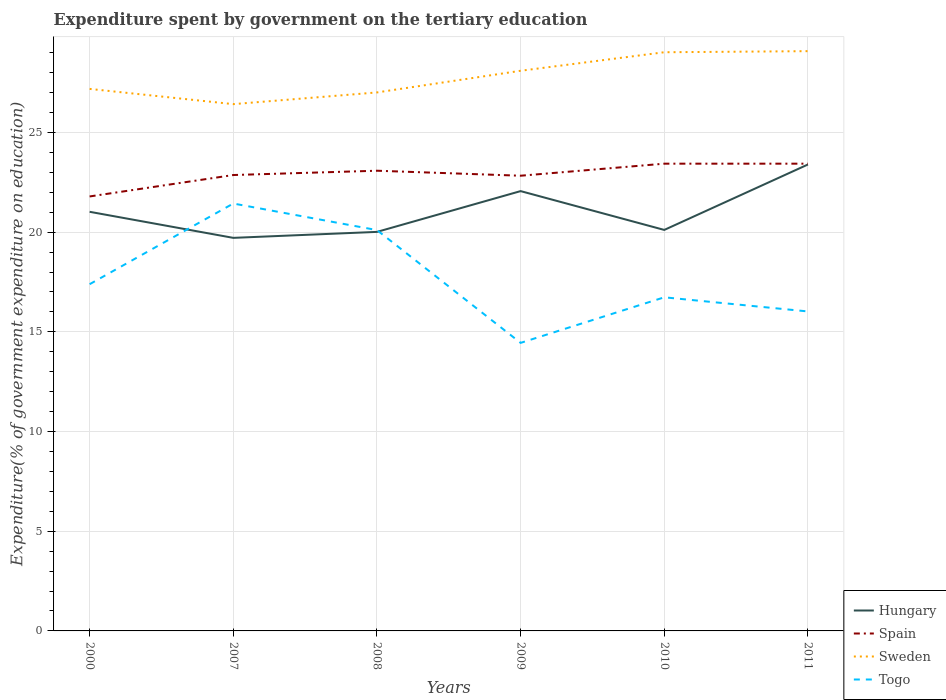How many different coloured lines are there?
Provide a succinct answer. 4. Does the line corresponding to Hungary intersect with the line corresponding to Spain?
Provide a short and direct response. No. Across all years, what is the maximum expenditure spent by government on the tertiary education in Togo?
Give a very brief answer. 14.45. In which year was the expenditure spent by government on the tertiary education in Sweden maximum?
Your answer should be compact. 2007. What is the total expenditure spent by government on the tertiary education in Spain in the graph?
Make the answer very short. -1.04. What is the difference between the highest and the second highest expenditure spent by government on the tertiary education in Hungary?
Your response must be concise. 3.68. What is the difference between the highest and the lowest expenditure spent by government on the tertiary education in Hungary?
Keep it short and to the point. 2. How many lines are there?
Offer a very short reply. 4. How many years are there in the graph?
Provide a succinct answer. 6. What is the difference between two consecutive major ticks on the Y-axis?
Provide a succinct answer. 5. Are the values on the major ticks of Y-axis written in scientific E-notation?
Your answer should be compact. No. Does the graph contain any zero values?
Provide a succinct answer. No. Where does the legend appear in the graph?
Provide a short and direct response. Bottom right. What is the title of the graph?
Give a very brief answer. Expenditure spent by government on the tertiary education. What is the label or title of the X-axis?
Make the answer very short. Years. What is the label or title of the Y-axis?
Provide a succinct answer. Expenditure(% of government expenditure on education). What is the Expenditure(% of government expenditure on education) in Hungary in 2000?
Provide a succinct answer. 21.02. What is the Expenditure(% of government expenditure on education) of Spain in 2000?
Offer a terse response. 21.79. What is the Expenditure(% of government expenditure on education) in Sweden in 2000?
Your answer should be compact. 27.18. What is the Expenditure(% of government expenditure on education) in Togo in 2000?
Provide a short and direct response. 17.39. What is the Expenditure(% of government expenditure on education) of Hungary in 2007?
Keep it short and to the point. 19.71. What is the Expenditure(% of government expenditure on education) of Spain in 2007?
Your answer should be very brief. 22.86. What is the Expenditure(% of government expenditure on education) of Sweden in 2007?
Your answer should be compact. 26.42. What is the Expenditure(% of government expenditure on education) in Togo in 2007?
Offer a terse response. 21.43. What is the Expenditure(% of government expenditure on education) of Hungary in 2008?
Provide a short and direct response. 20.01. What is the Expenditure(% of government expenditure on education) in Spain in 2008?
Make the answer very short. 23.08. What is the Expenditure(% of government expenditure on education) of Sweden in 2008?
Provide a short and direct response. 27.01. What is the Expenditure(% of government expenditure on education) of Togo in 2008?
Offer a terse response. 20.1. What is the Expenditure(% of government expenditure on education) in Hungary in 2009?
Offer a very short reply. 22.06. What is the Expenditure(% of government expenditure on education) of Spain in 2009?
Your response must be concise. 22.83. What is the Expenditure(% of government expenditure on education) in Sweden in 2009?
Make the answer very short. 28.09. What is the Expenditure(% of government expenditure on education) of Togo in 2009?
Offer a terse response. 14.45. What is the Expenditure(% of government expenditure on education) of Hungary in 2010?
Your answer should be compact. 20.11. What is the Expenditure(% of government expenditure on education) in Spain in 2010?
Your response must be concise. 23.43. What is the Expenditure(% of government expenditure on education) in Sweden in 2010?
Provide a succinct answer. 29.02. What is the Expenditure(% of government expenditure on education) in Togo in 2010?
Give a very brief answer. 16.73. What is the Expenditure(% of government expenditure on education) of Hungary in 2011?
Keep it short and to the point. 23.39. What is the Expenditure(% of government expenditure on education) in Spain in 2011?
Offer a terse response. 23.43. What is the Expenditure(% of government expenditure on education) of Sweden in 2011?
Provide a succinct answer. 29.08. What is the Expenditure(% of government expenditure on education) in Togo in 2011?
Provide a succinct answer. 16.02. Across all years, what is the maximum Expenditure(% of government expenditure on education) in Hungary?
Your answer should be compact. 23.39. Across all years, what is the maximum Expenditure(% of government expenditure on education) of Spain?
Keep it short and to the point. 23.43. Across all years, what is the maximum Expenditure(% of government expenditure on education) in Sweden?
Keep it short and to the point. 29.08. Across all years, what is the maximum Expenditure(% of government expenditure on education) of Togo?
Your answer should be very brief. 21.43. Across all years, what is the minimum Expenditure(% of government expenditure on education) in Hungary?
Your response must be concise. 19.71. Across all years, what is the minimum Expenditure(% of government expenditure on education) in Spain?
Keep it short and to the point. 21.79. Across all years, what is the minimum Expenditure(% of government expenditure on education) of Sweden?
Provide a succinct answer. 26.42. Across all years, what is the minimum Expenditure(% of government expenditure on education) in Togo?
Give a very brief answer. 14.45. What is the total Expenditure(% of government expenditure on education) in Hungary in the graph?
Offer a terse response. 126.31. What is the total Expenditure(% of government expenditure on education) in Spain in the graph?
Make the answer very short. 137.43. What is the total Expenditure(% of government expenditure on education) in Sweden in the graph?
Your response must be concise. 166.8. What is the total Expenditure(% of government expenditure on education) in Togo in the graph?
Your response must be concise. 106.13. What is the difference between the Expenditure(% of government expenditure on education) in Hungary in 2000 and that in 2007?
Keep it short and to the point. 1.31. What is the difference between the Expenditure(% of government expenditure on education) of Spain in 2000 and that in 2007?
Provide a succinct answer. -1.07. What is the difference between the Expenditure(% of government expenditure on education) in Sweden in 2000 and that in 2007?
Offer a terse response. 0.76. What is the difference between the Expenditure(% of government expenditure on education) in Togo in 2000 and that in 2007?
Ensure brevity in your answer.  -4.05. What is the difference between the Expenditure(% of government expenditure on education) of Hungary in 2000 and that in 2008?
Ensure brevity in your answer.  1.01. What is the difference between the Expenditure(% of government expenditure on education) of Spain in 2000 and that in 2008?
Make the answer very short. -1.29. What is the difference between the Expenditure(% of government expenditure on education) in Sweden in 2000 and that in 2008?
Ensure brevity in your answer.  0.18. What is the difference between the Expenditure(% of government expenditure on education) of Togo in 2000 and that in 2008?
Provide a short and direct response. -2.71. What is the difference between the Expenditure(% of government expenditure on education) of Hungary in 2000 and that in 2009?
Keep it short and to the point. -1.04. What is the difference between the Expenditure(% of government expenditure on education) in Spain in 2000 and that in 2009?
Keep it short and to the point. -1.04. What is the difference between the Expenditure(% of government expenditure on education) of Sweden in 2000 and that in 2009?
Ensure brevity in your answer.  -0.91. What is the difference between the Expenditure(% of government expenditure on education) in Togo in 2000 and that in 2009?
Make the answer very short. 2.94. What is the difference between the Expenditure(% of government expenditure on education) in Hungary in 2000 and that in 2010?
Offer a terse response. 0.91. What is the difference between the Expenditure(% of government expenditure on education) of Spain in 2000 and that in 2010?
Your response must be concise. -1.64. What is the difference between the Expenditure(% of government expenditure on education) of Sweden in 2000 and that in 2010?
Keep it short and to the point. -1.84. What is the difference between the Expenditure(% of government expenditure on education) in Togo in 2000 and that in 2010?
Offer a terse response. 0.66. What is the difference between the Expenditure(% of government expenditure on education) of Hungary in 2000 and that in 2011?
Your response must be concise. -2.37. What is the difference between the Expenditure(% of government expenditure on education) in Spain in 2000 and that in 2011?
Offer a terse response. -1.64. What is the difference between the Expenditure(% of government expenditure on education) of Sweden in 2000 and that in 2011?
Your response must be concise. -1.89. What is the difference between the Expenditure(% of government expenditure on education) in Togo in 2000 and that in 2011?
Your answer should be compact. 1.37. What is the difference between the Expenditure(% of government expenditure on education) in Hungary in 2007 and that in 2008?
Your answer should be compact. -0.3. What is the difference between the Expenditure(% of government expenditure on education) in Spain in 2007 and that in 2008?
Make the answer very short. -0.22. What is the difference between the Expenditure(% of government expenditure on education) of Sweden in 2007 and that in 2008?
Provide a short and direct response. -0.59. What is the difference between the Expenditure(% of government expenditure on education) in Togo in 2007 and that in 2008?
Offer a very short reply. 1.33. What is the difference between the Expenditure(% of government expenditure on education) of Hungary in 2007 and that in 2009?
Keep it short and to the point. -2.34. What is the difference between the Expenditure(% of government expenditure on education) of Spain in 2007 and that in 2009?
Provide a short and direct response. 0.03. What is the difference between the Expenditure(% of government expenditure on education) of Sweden in 2007 and that in 2009?
Offer a terse response. -1.67. What is the difference between the Expenditure(% of government expenditure on education) in Togo in 2007 and that in 2009?
Offer a terse response. 6.99. What is the difference between the Expenditure(% of government expenditure on education) of Hungary in 2007 and that in 2010?
Offer a terse response. -0.4. What is the difference between the Expenditure(% of government expenditure on education) of Spain in 2007 and that in 2010?
Make the answer very short. -0.57. What is the difference between the Expenditure(% of government expenditure on education) in Sweden in 2007 and that in 2010?
Give a very brief answer. -2.6. What is the difference between the Expenditure(% of government expenditure on education) in Togo in 2007 and that in 2010?
Your answer should be compact. 4.7. What is the difference between the Expenditure(% of government expenditure on education) of Hungary in 2007 and that in 2011?
Give a very brief answer. -3.68. What is the difference between the Expenditure(% of government expenditure on education) of Spain in 2007 and that in 2011?
Give a very brief answer. -0.57. What is the difference between the Expenditure(% of government expenditure on education) in Sweden in 2007 and that in 2011?
Give a very brief answer. -2.66. What is the difference between the Expenditure(% of government expenditure on education) of Togo in 2007 and that in 2011?
Your answer should be compact. 5.41. What is the difference between the Expenditure(% of government expenditure on education) of Hungary in 2008 and that in 2009?
Keep it short and to the point. -2.05. What is the difference between the Expenditure(% of government expenditure on education) in Spain in 2008 and that in 2009?
Ensure brevity in your answer.  0.25. What is the difference between the Expenditure(% of government expenditure on education) of Sweden in 2008 and that in 2009?
Ensure brevity in your answer.  -1.09. What is the difference between the Expenditure(% of government expenditure on education) of Togo in 2008 and that in 2009?
Give a very brief answer. 5.66. What is the difference between the Expenditure(% of government expenditure on education) of Hungary in 2008 and that in 2010?
Provide a succinct answer. -0.1. What is the difference between the Expenditure(% of government expenditure on education) of Spain in 2008 and that in 2010?
Provide a short and direct response. -0.35. What is the difference between the Expenditure(% of government expenditure on education) in Sweden in 2008 and that in 2010?
Provide a succinct answer. -2.02. What is the difference between the Expenditure(% of government expenditure on education) of Togo in 2008 and that in 2010?
Make the answer very short. 3.37. What is the difference between the Expenditure(% of government expenditure on education) of Hungary in 2008 and that in 2011?
Give a very brief answer. -3.38. What is the difference between the Expenditure(% of government expenditure on education) of Spain in 2008 and that in 2011?
Keep it short and to the point. -0.35. What is the difference between the Expenditure(% of government expenditure on education) of Sweden in 2008 and that in 2011?
Give a very brief answer. -2.07. What is the difference between the Expenditure(% of government expenditure on education) in Togo in 2008 and that in 2011?
Your response must be concise. 4.08. What is the difference between the Expenditure(% of government expenditure on education) in Hungary in 2009 and that in 2010?
Give a very brief answer. 1.95. What is the difference between the Expenditure(% of government expenditure on education) of Spain in 2009 and that in 2010?
Provide a succinct answer. -0.6. What is the difference between the Expenditure(% of government expenditure on education) of Sweden in 2009 and that in 2010?
Give a very brief answer. -0.93. What is the difference between the Expenditure(% of government expenditure on education) in Togo in 2009 and that in 2010?
Make the answer very short. -2.29. What is the difference between the Expenditure(% of government expenditure on education) in Hungary in 2009 and that in 2011?
Provide a short and direct response. -1.33. What is the difference between the Expenditure(% of government expenditure on education) of Spain in 2009 and that in 2011?
Your answer should be compact. -0.6. What is the difference between the Expenditure(% of government expenditure on education) in Sweden in 2009 and that in 2011?
Offer a very short reply. -0.98. What is the difference between the Expenditure(% of government expenditure on education) in Togo in 2009 and that in 2011?
Your answer should be compact. -1.58. What is the difference between the Expenditure(% of government expenditure on education) of Hungary in 2010 and that in 2011?
Your answer should be compact. -3.28. What is the difference between the Expenditure(% of government expenditure on education) of Sweden in 2010 and that in 2011?
Provide a succinct answer. -0.05. What is the difference between the Expenditure(% of government expenditure on education) in Togo in 2010 and that in 2011?
Make the answer very short. 0.71. What is the difference between the Expenditure(% of government expenditure on education) in Hungary in 2000 and the Expenditure(% of government expenditure on education) in Spain in 2007?
Keep it short and to the point. -1.84. What is the difference between the Expenditure(% of government expenditure on education) in Hungary in 2000 and the Expenditure(% of government expenditure on education) in Sweden in 2007?
Offer a terse response. -5.4. What is the difference between the Expenditure(% of government expenditure on education) of Hungary in 2000 and the Expenditure(% of government expenditure on education) of Togo in 2007?
Give a very brief answer. -0.42. What is the difference between the Expenditure(% of government expenditure on education) in Spain in 2000 and the Expenditure(% of government expenditure on education) in Sweden in 2007?
Offer a very short reply. -4.63. What is the difference between the Expenditure(% of government expenditure on education) of Spain in 2000 and the Expenditure(% of government expenditure on education) of Togo in 2007?
Offer a very short reply. 0.35. What is the difference between the Expenditure(% of government expenditure on education) in Sweden in 2000 and the Expenditure(% of government expenditure on education) in Togo in 2007?
Your response must be concise. 5.75. What is the difference between the Expenditure(% of government expenditure on education) of Hungary in 2000 and the Expenditure(% of government expenditure on education) of Spain in 2008?
Provide a succinct answer. -2.06. What is the difference between the Expenditure(% of government expenditure on education) of Hungary in 2000 and the Expenditure(% of government expenditure on education) of Sweden in 2008?
Keep it short and to the point. -5.99. What is the difference between the Expenditure(% of government expenditure on education) of Hungary in 2000 and the Expenditure(% of government expenditure on education) of Togo in 2008?
Your answer should be very brief. 0.92. What is the difference between the Expenditure(% of government expenditure on education) of Spain in 2000 and the Expenditure(% of government expenditure on education) of Sweden in 2008?
Provide a short and direct response. -5.22. What is the difference between the Expenditure(% of government expenditure on education) in Spain in 2000 and the Expenditure(% of government expenditure on education) in Togo in 2008?
Your answer should be very brief. 1.69. What is the difference between the Expenditure(% of government expenditure on education) of Sweden in 2000 and the Expenditure(% of government expenditure on education) of Togo in 2008?
Your response must be concise. 7.08. What is the difference between the Expenditure(% of government expenditure on education) of Hungary in 2000 and the Expenditure(% of government expenditure on education) of Spain in 2009?
Your answer should be very brief. -1.81. What is the difference between the Expenditure(% of government expenditure on education) in Hungary in 2000 and the Expenditure(% of government expenditure on education) in Sweden in 2009?
Give a very brief answer. -7.07. What is the difference between the Expenditure(% of government expenditure on education) in Hungary in 2000 and the Expenditure(% of government expenditure on education) in Togo in 2009?
Offer a very short reply. 6.57. What is the difference between the Expenditure(% of government expenditure on education) of Spain in 2000 and the Expenditure(% of government expenditure on education) of Sweden in 2009?
Provide a short and direct response. -6.3. What is the difference between the Expenditure(% of government expenditure on education) in Spain in 2000 and the Expenditure(% of government expenditure on education) in Togo in 2009?
Provide a succinct answer. 7.34. What is the difference between the Expenditure(% of government expenditure on education) of Sweden in 2000 and the Expenditure(% of government expenditure on education) of Togo in 2009?
Offer a very short reply. 12.74. What is the difference between the Expenditure(% of government expenditure on education) in Hungary in 2000 and the Expenditure(% of government expenditure on education) in Spain in 2010?
Make the answer very short. -2.41. What is the difference between the Expenditure(% of government expenditure on education) in Hungary in 2000 and the Expenditure(% of government expenditure on education) in Sweden in 2010?
Keep it short and to the point. -8. What is the difference between the Expenditure(% of government expenditure on education) in Hungary in 2000 and the Expenditure(% of government expenditure on education) in Togo in 2010?
Provide a succinct answer. 4.29. What is the difference between the Expenditure(% of government expenditure on education) of Spain in 2000 and the Expenditure(% of government expenditure on education) of Sweden in 2010?
Offer a terse response. -7.23. What is the difference between the Expenditure(% of government expenditure on education) of Spain in 2000 and the Expenditure(% of government expenditure on education) of Togo in 2010?
Your response must be concise. 5.06. What is the difference between the Expenditure(% of government expenditure on education) in Sweden in 2000 and the Expenditure(% of government expenditure on education) in Togo in 2010?
Make the answer very short. 10.45. What is the difference between the Expenditure(% of government expenditure on education) of Hungary in 2000 and the Expenditure(% of government expenditure on education) of Spain in 2011?
Provide a short and direct response. -2.41. What is the difference between the Expenditure(% of government expenditure on education) of Hungary in 2000 and the Expenditure(% of government expenditure on education) of Sweden in 2011?
Provide a succinct answer. -8.06. What is the difference between the Expenditure(% of government expenditure on education) in Hungary in 2000 and the Expenditure(% of government expenditure on education) in Togo in 2011?
Make the answer very short. 5. What is the difference between the Expenditure(% of government expenditure on education) of Spain in 2000 and the Expenditure(% of government expenditure on education) of Sweden in 2011?
Your answer should be compact. -7.29. What is the difference between the Expenditure(% of government expenditure on education) of Spain in 2000 and the Expenditure(% of government expenditure on education) of Togo in 2011?
Ensure brevity in your answer.  5.77. What is the difference between the Expenditure(% of government expenditure on education) in Sweden in 2000 and the Expenditure(% of government expenditure on education) in Togo in 2011?
Provide a succinct answer. 11.16. What is the difference between the Expenditure(% of government expenditure on education) in Hungary in 2007 and the Expenditure(% of government expenditure on education) in Spain in 2008?
Offer a very short reply. -3.37. What is the difference between the Expenditure(% of government expenditure on education) of Hungary in 2007 and the Expenditure(% of government expenditure on education) of Sweden in 2008?
Provide a succinct answer. -7.29. What is the difference between the Expenditure(% of government expenditure on education) of Hungary in 2007 and the Expenditure(% of government expenditure on education) of Togo in 2008?
Your response must be concise. -0.39. What is the difference between the Expenditure(% of government expenditure on education) of Spain in 2007 and the Expenditure(% of government expenditure on education) of Sweden in 2008?
Ensure brevity in your answer.  -4.14. What is the difference between the Expenditure(% of government expenditure on education) in Spain in 2007 and the Expenditure(% of government expenditure on education) in Togo in 2008?
Provide a short and direct response. 2.76. What is the difference between the Expenditure(% of government expenditure on education) of Sweden in 2007 and the Expenditure(% of government expenditure on education) of Togo in 2008?
Provide a short and direct response. 6.32. What is the difference between the Expenditure(% of government expenditure on education) in Hungary in 2007 and the Expenditure(% of government expenditure on education) in Spain in 2009?
Give a very brief answer. -3.12. What is the difference between the Expenditure(% of government expenditure on education) in Hungary in 2007 and the Expenditure(% of government expenditure on education) in Sweden in 2009?
Offer a very short reply. -8.38. What is the difference between the Expenditure(% of government expenditure on education) of Hungary in 2007 and the Expenditure(% of government expenditure on education) of Togo in 2009?
Keep it short and to the point. 5.27. What is the difference between the Expenditure(% of government expenditure on education) in Spain in 2007 and the Expenditure(% of government expenditure on education) in Sweden in 2009?
Your response must be concise. -5.23. What is the difference between the Expenditure(% of government expenditure on education) of Spain in 2007 and the Expenditure(% of government expenditure on education) of Togo in 2009?
Give a very brief answer. 8.42. What is the difference between the Expenditure(% of government expenditure on education) in Sweden in 2007 and the Expenditure(% of government expenditure on education) in Togo in 2009?
Give a very brief answer. 11.97. What is the difference between the Expenditure(% of government expenditure on education) in Hungary in 2007 and the Expenditure(% of government expenditure on education) in Spain in 2010?
Keep it short and to the point. -3.72. What is the difference between the Expenditure(% of government expenditure on education) in Hungary in 2007 and the Expenditure(% of government expenditure on education) in Sweden in 2010?
Ensure brevity in your answer.  -9.31. What is the difference between the Expenditure(% of government expenditure on education) in Hungary in 2007 and the Expenditure(% of government expenditure on education) in Togo in 2010?
Provide a succinct answer. 2.98. What is the difference between the Expenditure(% of government expenditure on education) in Spain in 2007 and the Expenditure(% of government expenditure on education) in Sweden in 2010?
Keep it short and to the point. -6.16. What is the difference between the Expenditure(% of government expenditure on education) of Spain in 2007 and the Expenditure(% of government expenditure on education) of Togo in 2010?
Provide a succinct answer. 6.13. What is the difference between the Expenditure(% of government expenditure on education) in Sweden in 2007 and the Expenditure(% of government expenditure on education) in Togo in 2010?
Keep it short and to the point. 9.69. What is the difference between the Expenditure(% of government expenditure on education) of Hungary in 2007 and the Expenditure(% of government expenditure on education) of Spain in 2011?
Provide a short and direct response. -3.72. What is the difference between the Expenditure(% of government expenditure on education) of Hungary in 2007 and the Expenditure(% of government expenditure on education) of Sweden in 2011?
Ensure brevity in your answer.  -9.36. What is the difference between the Expenditure(% of government expenditure on education) of Hungary in 2007 and the Expenditure(% of government expenditure on education) of Togo in 2011?
Offer a terse response. 3.69. What is the difference between the Expenditure(% of government expenditure on education) in Spain in 2007 and the Expenditure(% of government expenditure on education) in Sweden in 2011?
Your answer should be compact. -6.21. What is the difference between the Expenditure(% of government expenditure on education) of Spain in 2007 and the Expenditure(% of government expenditure on education) of Togo in 2011?
Offer a very short reply. 6.84. What is the difference between the Expenditure(% of government expenditure on education) of Sweden in 2007 and the Expenditure(% of government expenditure on education) of Togo in 2011?
Make the answer very short. 10.4. What is the difference between the Expenditure(% of government expenditure on education) in Hungary in 2008 and the Expenditure(% of government expenditure on education) in Spain in 2009?
Provide a short and direct response. -2.82. What is the difference between the Expenditure(% of government expenditure on education) in Hungary in 2008 and the Expenditure(% of government expenditure on education) in Sweden in 2009?
Provide a short and direct response. -8.08. What is the difference between the Expenditure(% of government expenditure on education) in Hungary in 2008 and the Expenditure(% of government expenditure on education) in Togo in 2009?
Offer a very short reply. 5.57. What is the difference between the Expenditure(% of government expenditure on education) of Spain in 2008 and the Expenditure(% of government expenditure on education) of Sweden in 2009?
Give a very brief answer. -5.01. What is the difference between the Expenditure(% of government expenditure on education) in Spain in 2008 and the Expenditure(% of government expenditure on education) in Togo in 2009?
Give a very brief answer. 8.63. What is the difference between the Expenditure(% of government expenditure on education) of Sweden in 2008 and the Expenditure(% of government expenditure on education) of Togo in 2009?
Make the answer very short. 12.56. What is the difference between the Expenditure(% of government expenditure on education) of Hungary in 2008 and the Expenditure(% of government expenditure on education) of Spain in 2010?
Give a very brief answer. -3.42. What is the difference between the Expenditure(% of government expenditure on education) in Hungary in 2008 and the Expenditure(% of government expenditure on education) in Sweden in 2010?
Make the answer very short. -9.01. What is the difference between the Expenditure(% of government expenditure on education) of Hungary in 2008 and the Expenditure(% of government expenditure on education) of Togo in 2010?
Give a very brief answer. 3.28. What is the difference between the Expenditure(% of government expenditure on education) in Spain in 2008 and the Expenditure(% of government expenditure on education) in Sweden in 2010?
Your answer should be compact. -5.94. What is the difference between the Expenditure(% of government expenditure on education) in Spain in 2008 and the Expenditure(% of government expenditure on education) in Togo in 2010?
Offer a terse response. 6.35. What is the difference between the Expenditure(% of government expenditure on education) in Sweden in 2008 and the Expenditure(% of government expenditure on education) in Togo in 2010?
Make the answer very short. 10.28. What is the difference between the Expenditure(% of government expenditure on education) in Hungary in 2008 and the Expenditure(% of government expenditure on education) in Spain in 2011?
Give a very brief answer. -3.42. What is the difference between the Expenditure(% of government expenditure on education) of Hungary in 2008 and the Expenditure(% of government expenditure on education) of Sweden in 2011?
Provide a succinct answer. -9.06. What is the difference between the Expenditure(% of government expenditure on education) in Hungary in 2008 and the Expenditure(% of government expenditure on education) in Togo in 2011?
Offer a very short reply. 3.99. What is the difference between the Expenditure(% of government expenditure on education) in Spain in 2008 and the Expenditure(% of government expenditure on education) in Sweden in 2011?
Your response must be concise. -6. What is the difference between the Expenditure(% of government expenditure on education) of Spain in 2008 and the Expenditure(% of government expenditure on education) of Togo in 2011?
Keep it short and to the point. 7.06. What is the difference between the Expenditure(% of government expenditure on education) of Sweden in 2008 and the Expenditure(% of government expenditure on education) of Togo in 2011?
Offer a terse response. 10.98. What is the difference between the Expenditure(% of government expenditure on education) in Hungary in 2009 and the Expenditure(% of government expenditure on education) in Spain in 2010?
Offer a terse response. -1.38. What is the difference between the Expenditure(% of government expenditure on education) in Hungary in 2009 and the Expenditure(% of government expenditure on education) in Sweden in 2010?
Offer a terse response. -6.96. What is the difference between the Expenditure(% of government expenditure on education) of Hungary in 2009 and the Expenditure(% of government expenditure on education) of Togo in 2010?
Keep it short and to the point. 5.33. What is the difference between the Expenditure(% of government expenditure on education) in Spain in 2009 and the Expenditure(% of government expenditure on education) in Sweden in 2010?
Your answer should be compact. -6.19. What is the difference between the Expenditure(% of government expenditure on education) in Spain in 2009 and the Expenditure(% of government expenditure on education) in Togo in 2010?
Provide a short and direct response. 6.1. What is the difference between the Expenditure(% of government expenditure on education) in Sweden in 2009 and the Expenditure(% of government expenditure on education) in Togo in 2010?
Provide a short and direct response. 11.36. What is the difference between the Expenditure(% of government expenditure on education) in Hungary in 2009 and the Expenditure(% of government expenditure on education) in Spain in 2011?
Your answer should be compact. -1.38. What is the difference between the Expenditure(% of government expenditure on education) of Hungary in 2009 and the Expenditure(% of government expenditure on education) of Sweden in 2011?
Your response must be concise. -7.02. What is the difference between the Expenditure(% of government expenditure on education) of Hungary in 2009 and the Expenditure(% of government expenditure on education) of Togo in 2011?
Make the answer very short. 6.04. What is the difference between the Expenditure(% of government expenditure on education) of Spain in 2009 and the Expenditure(% of government expenditure on education) of Sweden in 2011?
Give a very brief answer. -6.25. What is the difference between the Expenditure(% of government expenditure on education) in Spain in 2009 and the Expenditure(% of government expenditure on education) in Togo in 2011?
Your response must be concise. 6.81. What is the difference between the Expenditure(% of government expenditure on education) of Sweden in 2009 and the Expenditure(% of government expenditure on education) of Togo in 2011?
Provide a succinct answer. 12.07. What is the difference between the Expenditure(% of government expenditure on education) of Hungary in 2010 and the Expenditure(% of government expenditure on education) of Spain in 2011?
Your response must be concise. -3.32. What is the difference between the Expenditure(% of government expenditure on education) of Hungary in 2010 and the Expenditure(% of government expenditure on education) of Sweden in 2011?
Your answer should be compact. -8.97. What is the difference between the Expenditure(% of government expenditure on education) of Hungary in 2010 and the Expenditure(% of government expenditure on education) of Togo in 2011?
Keep it short and to the point. 4.09. What is the difference between the Expenditure(% of government expenditure on education) in Spain in 2010 and the Expenditure(% of government expenditure on education) in Sweden in 2011?
Offer a very short reply. -5.64. What is the difference between the Expenditure(% of government expenditure on education) in Spain in 2010 and the Expenditure(% of government expenditure on education) in Togo in 2011?
Your answer should be compact. 7.41. What is the difference between the Expenditure(% of government expenditure on education) of Sweden in 2010 and the Expenditure(% of government expenditure on education) of Togo in 2011?
Offer a terse response. 13. What is the average Expenditure(% of government expenditure on education) in Hungary per year?
Provide a succinct answer. 21.05. What is the average Expenditure(% of government expenditure on education) in Spain per year?
Your response must be concise. 22.9. What is the average Expenditure(% of government expenditure on education) in Sweden per year?
Give a very brief answer. 27.8. What is the average Expenditure(% of government expenditure on education) in Togo per year?
Offer a terse response. 17.69. In the year 2000, what is the difference between the Expenditure(% of government expenditure on education) of Hungary and Expenditure(% of government expenditure on education) of Spain?
Ensure brevity in your answer.  -0.77. In the year 2000, what is the difference between the Expenditure(% of government expenditure on education) of Hungary and Expenditure(% of government expenditure on education) of Sweden?
Keep it short and to the point. -6.16. In the year 2000, what is the difference between the Expenditure(% of government expenditure on education) of Hungary and Expenditure(% of government expenditure on education) of Togo?
Provide a short and direct response. 3.63. In the year 2000, what is the difference between the Expenditure(% of government expenditure on education) of Spain and Expenditure(% of government expenditure on education) of Sweden?
Offer a very short reply. -5.39. In the year 2000, what is the difference between the Expenditure(% of government expenditure on education) in Spain and Expenditure(% of government expenditure on education) in Togo?
Your response must be concise. 4.4. In the year 2000, what is the difference between the Expenditure(% of government expenditure on education) in Sweden and Expenditure(% of government expenditure on education) in Togo?
Keep it short and to the point. 9.79. In the year 2007, what is the difference between the Expenditure(% of government expenditure on education) in Hungary and Expenditure(% of government expenditure on education) in Spain?
Offer a terse response. -3.15. In the year 2007, what is the difference between the Expenditure(% of government expenditure on education) of Hungary and Expenditure(% of government expenditure on education) of Sweden?
Your response must be concise. -6.71. In the year 2007, what is the difference between the Expenditure(% of government expenditure on education) of Hungary and Expenditure(% of government expenditure on education) of Togo?
Ensure brevity in your answer.  -1.72. In the year 2007, what is the difference between the Expenditure(% of government expenditure on education) of Spain and Expenditure(% of government expenditure on education) of Sweden?
Offer a very short reply. -3.56. In the year 2007, what is the difference between the Expenditure(% of government expenditure on education) of Spain and Expenditure(% of government expenditure on education) of Togo?
Give a very brief answer. 1.43. In the year 2007, what is the difference between the Expenditure(% of government expenditure on education) of Sweden and Expenditure(% of government expenditure on education) of Togo?
Provide a short and direct response. 4.98. In the year 2008, what is the difference between the Expenditure(% of government expenditure on education) in Hungary and Expenditure(% of government expenditure on education) in Spain?
Your response must be concise. -3.07. In the year 2008, what is the difference between the Expenditure(% of government expenditure on education) of Hungary and Expenditure(% of government expenditure on education) of Sweden?
Your response must be concise. -6.99. In the year 2008, what is the difference between the Expenditure(% of government expenditure on education) of Hungary and Expenditure(% of government expenditure on education) of Togo?
Keep it short and to the point. -0.09. In the year 2008, what is the difference between the Expenditure(% of government expenditure on education) of Spain and Expenditure(% of government expenditure on education) of Sweden?
Your answer should be very brief. -3.93. In the year 2008, what is the difference between the Expenditure(% of government expenditure on education) in Spain and Expenditure(% of government expenditure on education) in Togo?
Make the answer very short. 2.98. In the year 2008, what is the difference between the Expenditure(% of government expenditure on education) in Sweden and Expenditure(% of government expenditure on education) in Togo?
Provide a succinct answer. 6.9. In the year 2009, what is the difference between the Expenditure(% of government expenditure on education) of Hungary and Expenditure(% of government expenditure on education) of Spain?
Provide a short and direct response. -0.77. In the year 2009, what is the difference between the Expenditure(% of government expenditure on education) of Hungary and Expenditure(% of government expenditure on education) of Sweden?
Make the answer very short. -6.04. In the year 2009, what is the difference between the Expenditure(% of government expenditure on education) of Hungary and Expenditure(% of government expenditure on education) of Togo?
Give a very brief answer. 7.61. In the year 2009, what is the difference between the Expenditure(% of government expenditure on education) in Spain and Expenditure(% of government expenditure on education) in Sweden?
Your answer should be very brief. -5.26. In the year 2009, what is the difference between the Expenditure(% of government expenditure on education) of Spain and Expenditure(% of government expenditure on education) of Togo?
Your answer should be compact. 8.38. In the year 2009, what is the difference between the Expenditure(% of government expenditure on education) of Sweden and Expenditure(% of government expenditure on education) of Togo?
Provide a short and direct response. 13.65. In the year 2010, what is the difference between the Expenditure(% of government expenditure on education) in Hungary and Expenditure(% of government expenditure on education) in Spain?
Make the answer very short. -3.32. In the year 2010, what is the difference between the Expenditure(% of government expenditure on education) in Hungary and Expenditure(% of government expenditure on education) in Sweden?
Give a very brief answer. -8.91. In the year 2010, what is the difference between the Expenditure(% of government expenditure on education) of Hungary and Expenditure(% of government expenditure on education) of Togo?
Your response must be concise. 3.38. In the year 2010, what is the difference between the Expenditure(% of government expenditure on education) of Spain and Expenditure(% of government expenditure on education) of Sweden?
Provide a short and direct response. -5.59. In the year 2010, what is the difference between the Expenditure(% of government expenditure on education) of Spain and Expenditure(% of government expenditure on education) of Togo?
Make the answer very short. 6.7. In the year 2010, what is the difference between the Expenditure(% of government expenditure on education) in Sweden and Expenditure(% of government expenditure on education) in Togo?
Your answer should be compact. 12.29. In the year 2011, what is the difference between the Expenditure(% of government expenditure on education) of Hungary and Expenditure(% of government expenditure on education) of Spain?
Your response must be concise. -0.04. In the year 2011, what is the difference between the Expenditure(% of government expenditure on education) of Hungary and Expenditure(% of government expenditure on education) of Sweden?
Keep it short and to the point. -5.68. In the year 2011, what is the difference between the Expenditure(% of government expenditure on education) in Hungary and Expenditure(% of government expenditure on education) in Togo?
Offer a very short reply. 7.37. In the year 2011, what is the difference between the Expenditure(% of government expenditure on education) of Spain and Expenditure(% of government expenditure on education) of Sweden?
Offer a very short reply. -5.64. In the year 2011, what is the difference between the Expenditure(% of government expenditure on education) in Spain and Expenditure(% of government expenditure on education) in Togo?
Provide a short and direct response. 7.41. In the year 2011, what is the difference between the Expenditure(% of government expenditure on education) in Sweden and Expenditure(% of government expenditure on education) in Togo?
Offer a terse response. 13.05. What is the ratio of the Expenditure(% of government expenditure on education) of Hungary in 2000 to that in 2007?
Give a very brief answer. 1.07. What is the ratio of the Expenditure(% of government expenditure on education) of Spain in 2000 to that in 2007?
Make the answer very short. 0.95. What is the ratio of the Expenditure(% of government expenditure on education) of Sweden in 2000 to that in 2007?
Provide a succinct answer. 1.03. What is the ratio of the Expenditure(% of government expenditure on education) in Togo in 2000 to that in 2007?
Provide a succinct answer. 0.81. What is the ratio of the Expenditure(% of government expenditure on education) in Hungary in 2000 to that in 2008?
Your response must be concise. 1.05. What is the ratio of the Expenditure(% of government expenditure on education) of Spain in 2000 to that in 2008?
Your answer should be compact. 0.94. What is the ratio of the Expenditure(% of government expenditure on education) in Togo in 2000 to that in 2008?
Offer a terse response. 0.86. What is the ratio of the Expenditure(% of government expenditure on education) in Hungary in 2000 to that in 2009?
Your response must be concise. 0.95. What is the ratio of the Expenditure(% of government expenditure on education) of Spain in 2000 to that in 2009?
Offer a terse response. 0.95. What is the ratio of the Expenditure(% of government expenditure on education) of Sweden in 2000 to that in 2009?
Make the answer very short. 0.97. What is the ratio of the Expenditure(% of government expenditure on education) in Togo in 2000 to that in 2009?
Your answer should be compact. 1.2. What is the ratio of the Expenditure(% of government expenditure on education) in Hungary in 2000 to that in 2010?
Your answer should be very brief. 1.05. What is the ratio of the Expenditure(% of government expenditure on education) in Spain in 2000 to that in 2010?
Provide a succinct answer. 0.93. What is the ratio of the Expenditure(% of government expenditure on education) of Sweden in 2000 to that in 2010?
Your response must be concise. 0.94. What is the ratio of the Expenditure(% of government expenditure on education) in Togo in 2000 to that in 2010?
Your response must be concise. 1.04. What is the ratio of the Expenditure(% of government expenditure on education) of Hungary in 2000 to that in 2011?
Provide a short and direct response. 0.9. What is the ratio of the Expenditure(% of government expenditure on education) of Spain in 2000 to that in 2011?
Keep it short and to the point. 0.93. What is the ratio of the Expenditure(% of government expenditure on education) of Sweden in 2000 to that in 2011?
Give a very brief answer. 0.93. What is the ratio of the Expenditure(% of government expenditure on education) in Togo in 2000 to that in 2011?
Offer a very short reply. 1.09. What is the ratio of the Expenditure(% of government expenditure on education) of Hungary in 2007 to that in 2008?
Ensure brevity in your answer.  0.99. What is the ratio of the Expenditure(% of government expenditure on education) in Spain in 2007 to that in 2008?
Offer a terse response. 0.99. What is the ratio of the Expenditure(% of government expenditure on education) of Sweden in 2007 to that in 2008?
Give a very brief answer. 0.98. What is the ratio of the Expenditure(% of government expenditure on education) of Togo in 2007 to that in 2008?
Make the answer very short. 1.07. What is the ratio of the Expenditure(% of government expenditure on education) in Hungary in 2007 to that in 2009?
Your answer should be very brief. 0.89. What is the ratio of the Expenditure(% of government expenditure on education) of Spain in 2007 to that in 2009?
Your answer should be very brief. 1. What is the ratio of the Expenditure(% of government expenditure on education) in Sweden in 2007 to that in 2009?
Your answer should be very brief. 0.94. What is the ratio of the Expenditure(% of government expenditure on education) in Togo in 2007 to that in 2009?
Your response must be concise. 1.48. What is the ratio of the Expenditure(% of government expenditure on education) of Hungary in 2007 to that in 2010?
Ensure brevity in your answer.  0.98. What is the ratio of the Expenditure(% of government expenditure on education) in Spain in 2007 to that in 2010?
Provide a short and direct response. 0.98. What is the ratio of the Expenditure(% of government expenditure on education) of Sweden in 2007 to that in 2010?
Your response must be concise. 0.91. What is the ratio of the Expenditure(% of government expenditure on education) of Togo in 2007 to that in 2010?
Provide a short and direct response. 1.28. What is the ratio of the Expenditure(% of government expenditure on education) in Hungary in 2007 to that in 2011?
Provide a succinct answer. 0.84. What is the ratio of the Expenditure(% of government expenditure on education) in Spain in 2007 to that in 2011?
Offer a terse response. 0.98. What is the ratio of the Expenditure(% of government expenditure on education) in Sweden in 2007 to that in 2011?
Make the answer very short. 0.91. What is the ratio of the Expenditure(% of government expenditure on education) in Togo in 2007 to that in 2011?
Your response must be concise. 1.34. What is the ratio of the Expenditure(% of government expenditure on education) in Hungary in 2008 to that in 2009?
Provide a short and direct response. 0.91. What is the ratio of the Expenditure(% of government expenditure on education) in Spain in 2008 to that in 2009?
Make the answer very short. 1.01. What is the ratio of the Expenditure(% of government expenditure on education) of Sweden in 2008 to that in 2009?
Provide a succinct answer. 0.96. What is the ratio of the Expenditure(% of government expenditure on education) of Togo in 2008 to that in 2009?
Make the answer very short. 1.39. What is the ratio of the Expenditure(% of government expenditure on education) of Spain in 2008 to that in 2010?
Keep it short and to the point. 0.98. What is the ratio of the Expenditure(% of government expenditure on education) of Sweden in 2008 to that in 2010?
Provide a short and direct response. 0.93. What is the ratio of the Expenditure(% of government expenditure on education) in Togo in 2008 to that in 2010?
Your answer should be compact. 1.2. What is the ratio of the Expenditure(% of government expenditure on education) of Hungary in 2008 to that in 2011?
Keep it short and to the point. 0.86. What is the ratio of the Expenditure(% of government expenditure on education) of Spain in 2008 to that in 2011?
Ensure brevity in your answer.  0.98. What is the ratio of the Expenditure(% of government expenditure on education) of Sweden in 2008 to that in 2011?
Offer a very short reply. 0.93. What is the ratio of the Expenditure(% of government expenditure on education) in Togo in 2008 to that in 2011?
Give a very brief answer. 1.25. What is the ratio of the Expenditure(% of government expenditure on education) of Hungary in 2009 to that in 2010?
Make the answer very short. 1.1. What is the ratio of the Expenditure(% of government expenditure on education) of Spain in 2009 to that in 2010?
Ensure brevity in your answer.  0.97. What is the ratio of the Expenditure(% of government expenditure on education) of Sweden in 2009 to that in 2010?
Give a very brief answer. 0.97. What is the ratio of the Expenditure(% of government expenditure on education) in Togo in 2009 to that in 2010?
Your answer should be very brief. 0.86. What is the ratio of the Expenditure(% of government expenditure on education) of Hungary in 2009 to that in 2011?
Ensure brevity in your answer.  0.94. What is the ratio of the Expenditure(% of government expenditure on education) in Spain in 2009 to that in 2011?
Keep it short and to the point. 0.97. What is the ratio of the Expenditure(% of government expenditure on education) of Sweden in 2009 to that in 2011?
Provide a short and direct response. 0.97. What is the ratio of the Expenditure(% of government expenditure on education) in Togo in 2009 to that in 2011?
Ensure brevity in your answer.  0.9. What is the ratio of the Expenditure(% of government expenditure on education) in Hungary in 2010 to that in 2011?
Keep it short and to the point. 0.86. What is the ratio of the Expenditure(% of government expenditure on education) in Sweden in 2010 to that in 2011?
Your response must be concise. 1. What is the ratio of the Expenditure(% of government expenditure on education) in Togo in 2010 to that in 2011?
Your response must be concise. 1.04. What is the difference between the highest and the second highest Expenditure(% of government expenditure on education) in Hungary?
Offer a terse response. 1.33. What is the difference between the highest and the second highest Expenditure(% of government expenditure on education) in Spain?
Ensure brevity in your answer.  0. What is the difference between the highest and the second highest Expenditure(% of government expenditure on education) in Sweden?
Your answer should be compact. 0.05. What is the difference between the highest and the second highest Expenditure(% of government expenditure on education) of Togo?
Give a very brief answer. 1.33. What is the difference between the highest and the lowest Expenditure(% of government expenditure on education) of Hungary?
Your answer should be compact. 3.68. What is the difference between the highest and the lowest Expenditure(% of government expenditure on education) of Spain?
Give a very brief answer. 1.64. What is the difference between the highest and the lowest Expenditure(% of government expenditure on education) in Sweden?
Your response must be concise. 2.66. What is the difference between the highest and the lowest Expenditure(% of government expenditure on education) of Togo?
Ensure brevity in your answer.  6.99. 